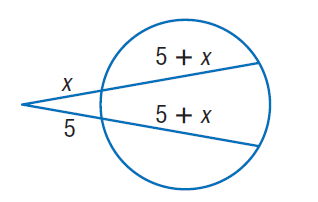Answer the mathemtical geometry problem and directly provide the correct option letter.
Question: Find x. Round to the nearest tenth if necessary. Assume that segments that appear to be tangent are tangent.
Choices: A: 5 B: 10 C: 15 D: 20 A 